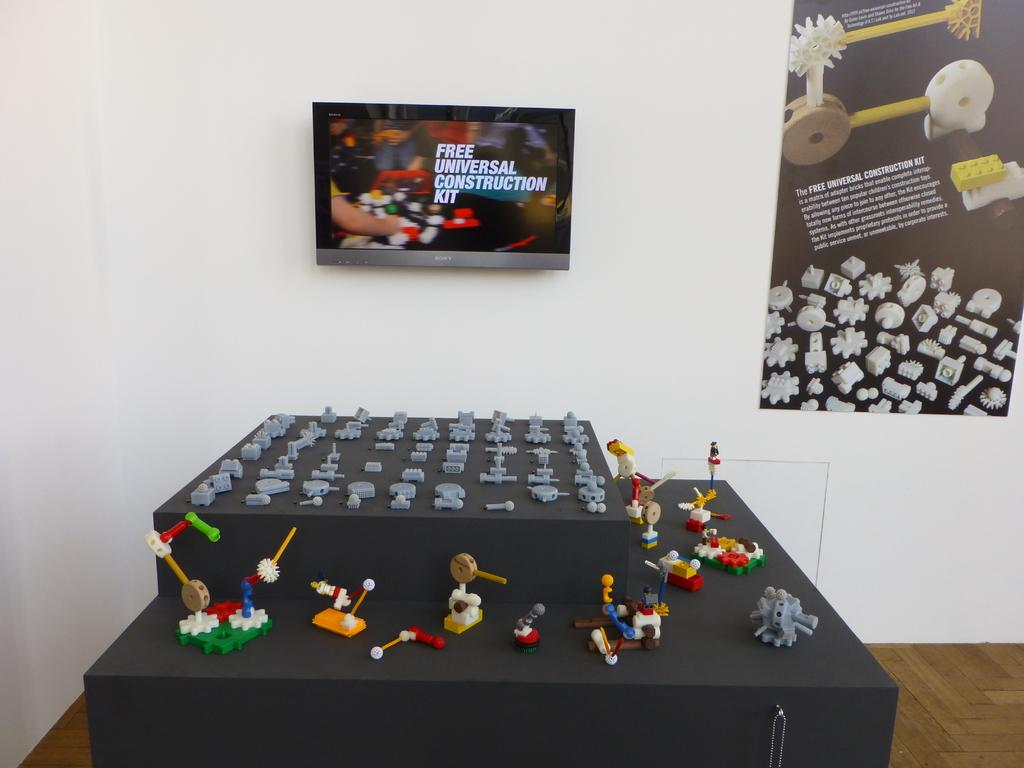<image>
Write a terse but informative summary of the picture. a Free Universal Construction Kit sign above the table 